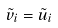Convert formula to latex. <formula><loc_0><loc_0><loc_500><loc_500>\tilde { v } _ { i } = \tilde { u } _ { i }</formula> 